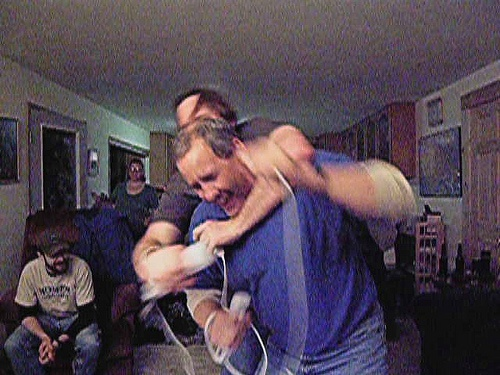Describe the objects in this image and their specific colors. I can see people in gray, navy, blue, black, and purple tones, people in gray, lightpink, black, and brown tones, people in gray, black, and darkgray tones, people in gray and tan tones, and chair in gray, black, and purple tones in this image. 